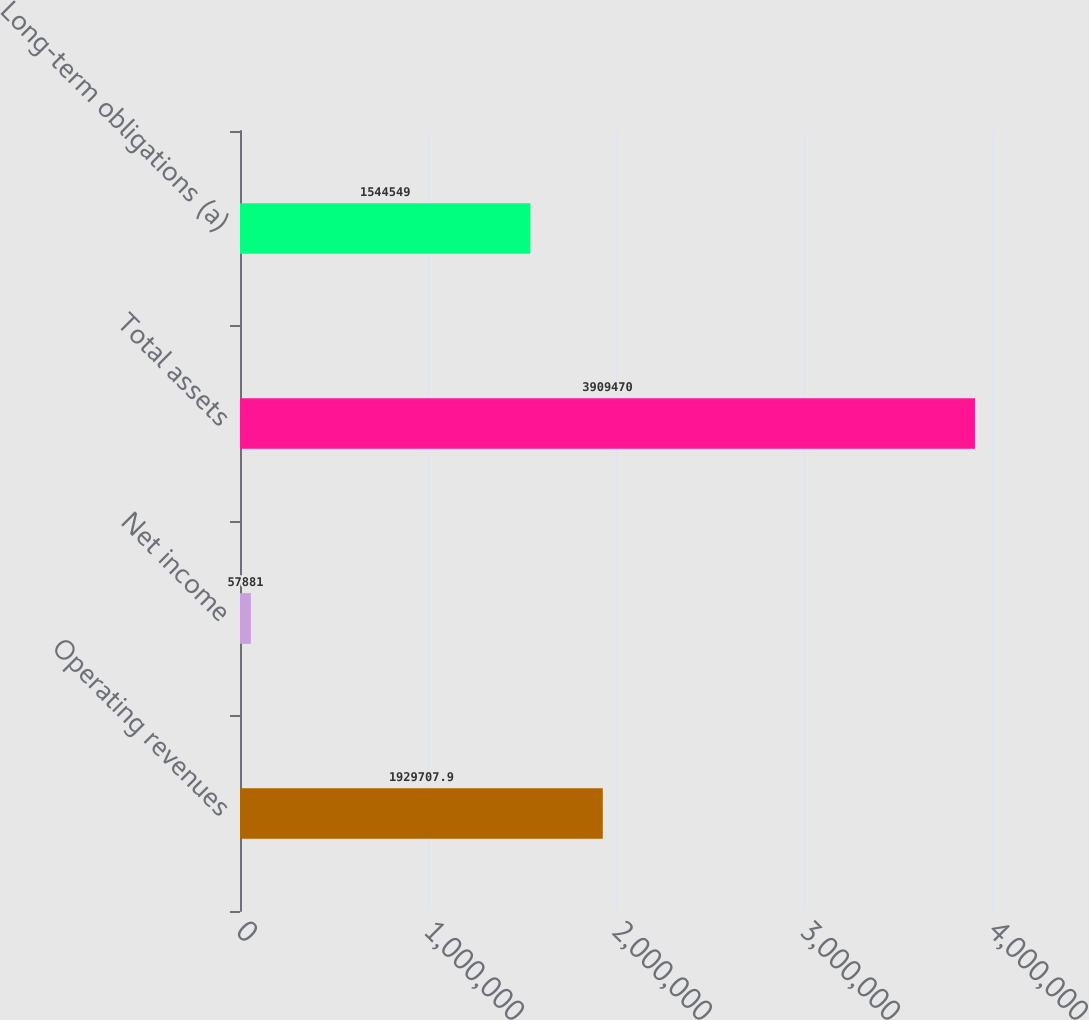Convert chart. <chart><loc_0><loc_0><loc_500><loc_500><bar_chart><fcel>Operating revenues<fcel>Net income<fcel>Total assets<fcel>Long-term obligations (a)<nl><fcel>1.92971e+06<fcel>57881<fcel>3.90947e+06<fcel>1.54455e+06<nl></chart> 